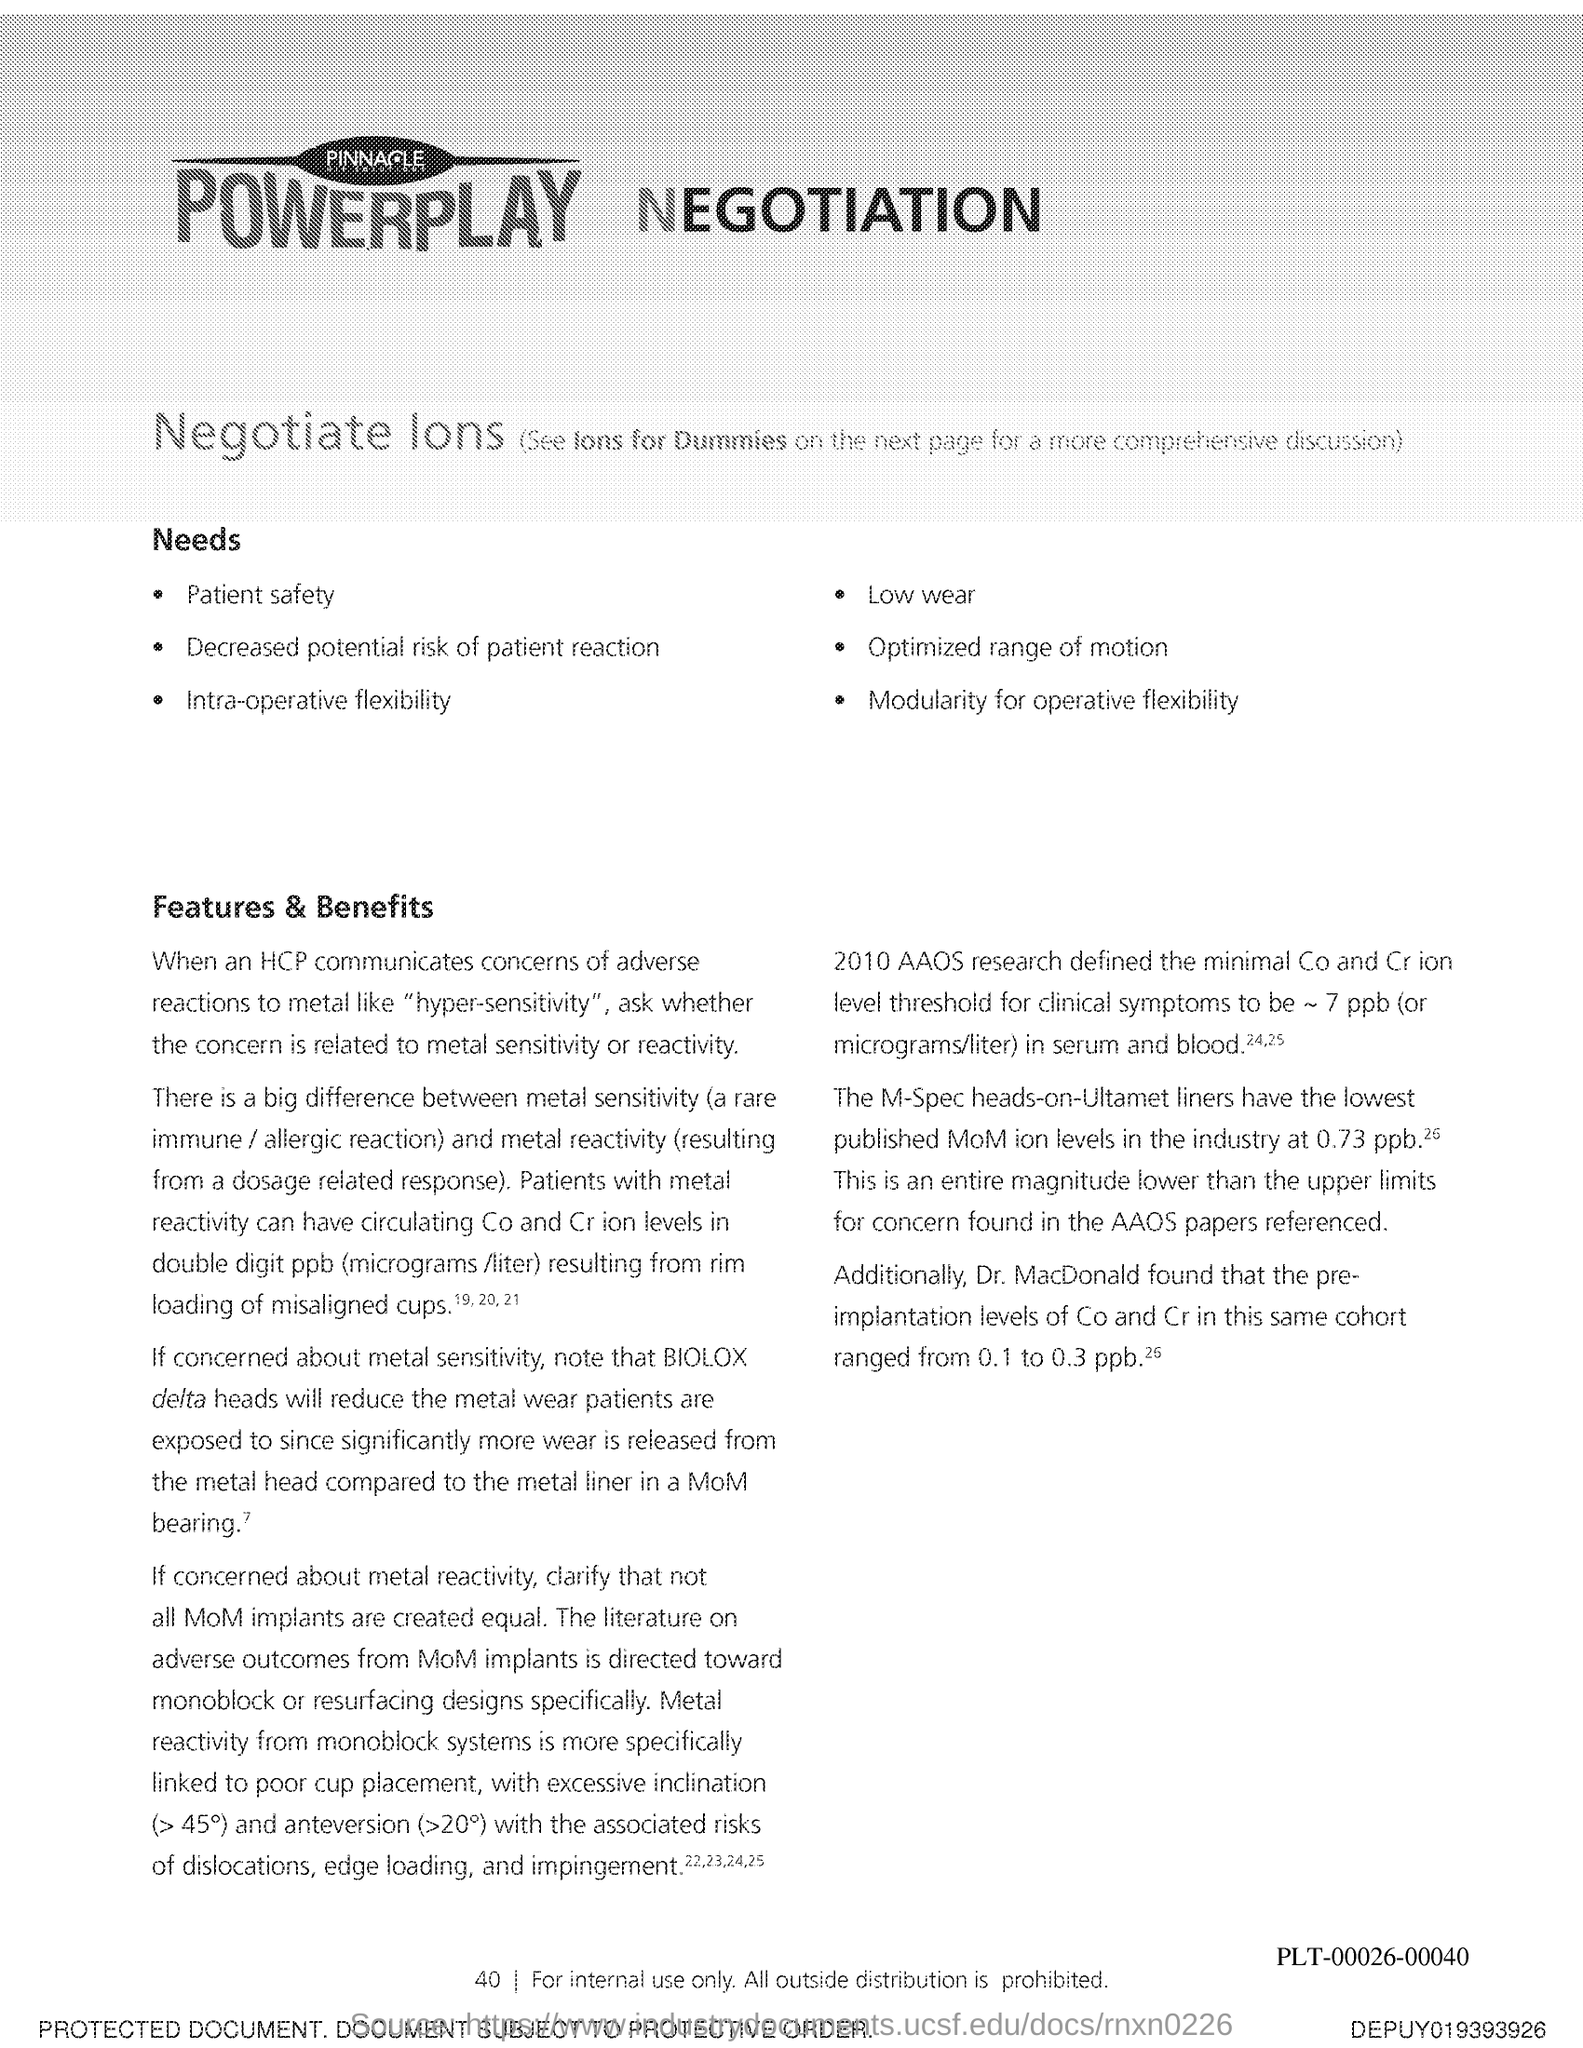What is the Page Number?
Offer a very short reply. 40. 